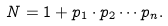<formula> <loc_0><loc_0><loc_500><loc_500>N = 1 + p _ { 1 } \cdot p _ { 2 } \cdots p _ { n } .</formula> 